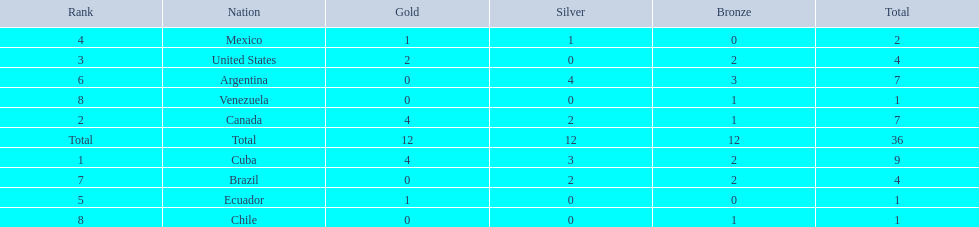Which nations participated? Cuba, Canada, United States, Mexico, Ecuador, Argentina, Brazil, Chile, Venezuela. Which nations won gold? Cuba, Canada, United States, Mexico, Ecuador. Which nations did not win silver? United States, Ecuador, Chile, Venezuela. Out of those countries previously listed, which nation won gold? United States. 